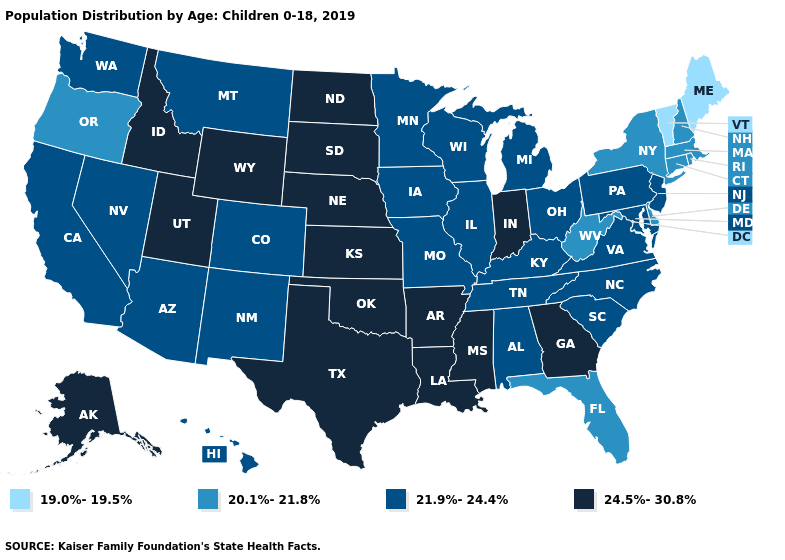What is the value of New Hampshire?
Give a very brief answer. 20.1%-21.8%. Which states hav the highest value in the South?
Write a very short answer. Arkansas, Georgia, Louisiana, Mississippi, Oklahoma, Texas. Does the map have missing data?
Answer briefly. No. What is the lowest value in the USA?
Write a very short answer. 19.0%-19.5%. Does Michigan have a lower value than South Dakota?
Keep it brief. Yes. What is the value of Indiana?
Keep it brief. 24.5%-30.8%. Name the states that have a value in the range 24.5%-30.8%?
Give a very brief answer. Alaska, Arkansas, Georgia, Idaho, Indiana, Kansas, Louisiana, Mississippi, Nebraska, North Dakota, Oklahoma, South Dakota, Texas, Utah, Wyoming. What is the value of Oregon?
Be succinct. 20.1%-21.8%. Does Nevada have the highest value in the USA?
Keep it brief. No. Does Alaska have the highest value in the West?
Concise answer only. Yes. Does Alaska have the highest value in the West?
Concise answer only. Yes. What is the lowest value in states that border Kansas?
Short answer required. 21.9%-24.4%. What is the value of New Hampshire?
Answer briefly. 20.1%-21.8%. What is the highest value in the USA?
Be succinct. 24.5%-30.8%. 